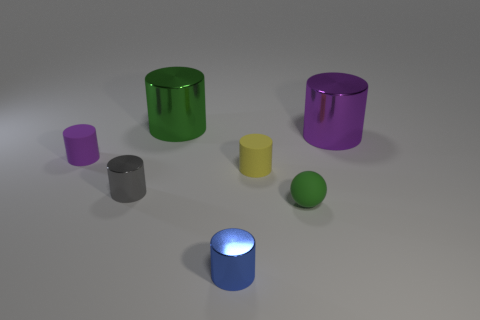There is a green object in front of the purple cylinder left of the small yellow matte thing; what is it made of?
Provide a succinct answer. Rubber. Is the size of the object in front of the green matte thing the same as the green cylinder that is to the right of the small purple cylinder?
Offer a very short reply. No. What number of tiny things are green cylinders or blue shiny things?
Your response must be concise. 1. What number of objects are either metallic objects that are on the right side of the large green thing or blue metal things?
Your answer should be compact. 2. How many other objects are the same shape as the blue thing?
Make the answer very short. 5. How many yellow objects are big objects or matte cylinders?
Offer a terse response. 1. What is the color of the other large object that is made of the same material as the large purple object?
Give a very brief answer. Green. Does the purple thing on the right side of the blue metallic cylinder have the same material as the green thing that is to the left of the blue cylinder?
Offer a very short reply. Yes. What is the material of the purple object left of the small rubber sphere?
Provide a succinct answer. Rubber. Do the tiny rubber thing that is to the left of the large green metal thing and the green thing that is behind the yellow rubber cylinder have the same shape?
Give a very brief answer. Yes. 